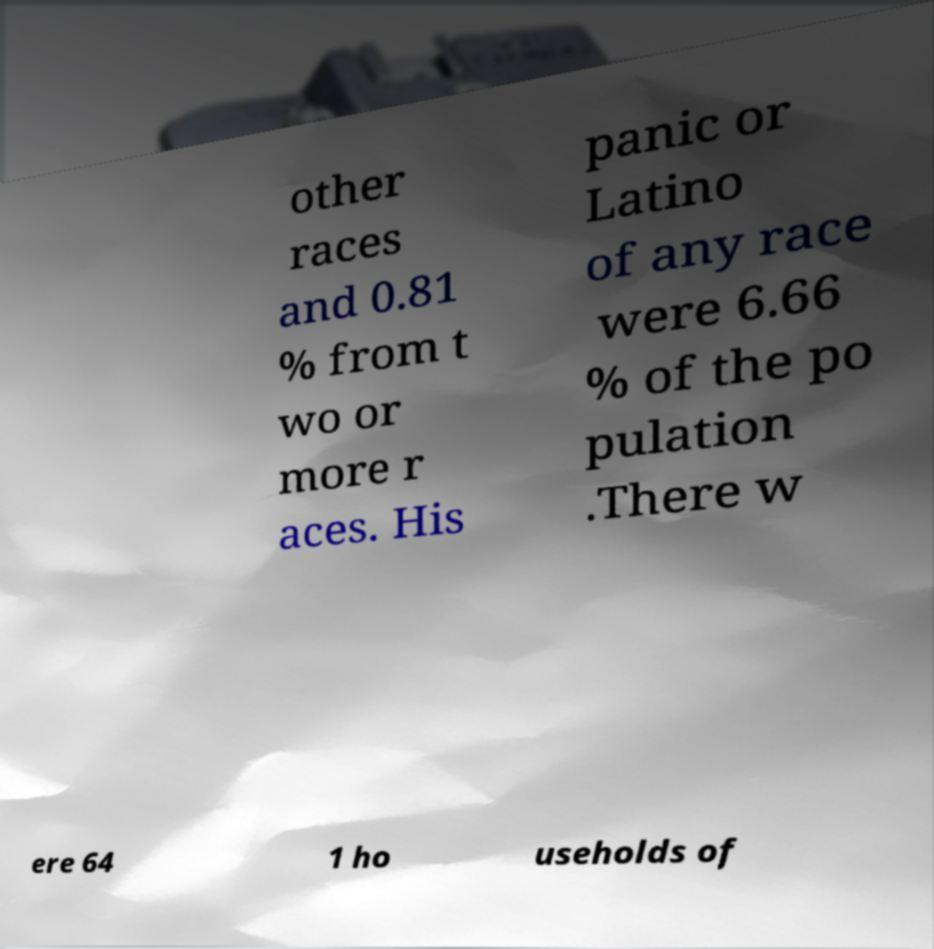Please read and relay the text visible in this image. What does it say? other races and 0.81 % from t wo or more r aces. His panic or Latino of any race were 6.66 % of the po pulation .There w ere 64 1 ho useholds of 